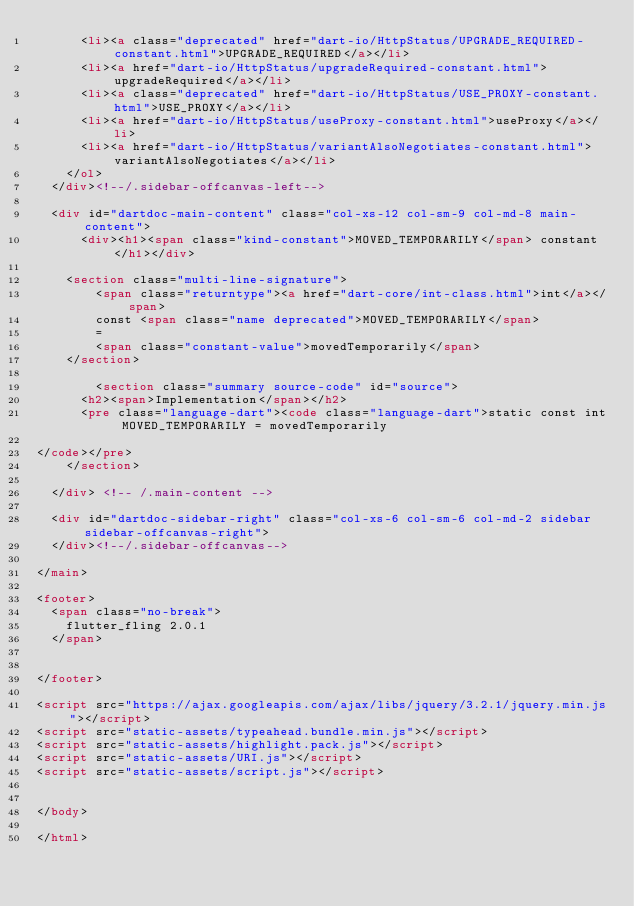<code> <loc_0><loc_0><loc_500><loc_500><_HTML_>      <li><a class="deprecated" href="dart-io/HttpStatus/UPGRADE_REQUIRED-constant.html">UPGRADE_REQUIRED</a></li>
      <li><a href="dart-io/HttpStatus/upgradeRequired-constant.html">upgradeRequired</a></li>
      <li><a class="deprecated" href="dart-io/HttpStatus/USE_PROXY-constant.html">USE_PROXY</a></li>
      <li><a href="dart-io/HttpStatus/useProxy-constant.html">useProxy</a></li>
      <li><a href="dart-io/HttpStatus/variantAlsoNegotiates-constant.html">variantAlsoNegotiates</a></li>
    </ol>
  </div><!--/.sidebar-offcanvas-left-->

  <div id="dartdoc-main-content" class="col-xs-12 col-sm-9 col-md-8 main-content">
      <div><h1><span class="kind-constant">MOVED_TEMPORARILY</span> constant</h1></div>

    <section class="multi-line-signature">
        <span class="returntype"><a href="dart-core/int-class.html">int</a></span>
        const <span class="name deprecated">MOVED_TEMPORARILY</span>
        =
        <span class="constant-value">movedTemporarily</span>
    </section>

        <section class="summary source-code" id="source">
      <h2><span>Implementation</span></h2>
      <pre class="language-dart"><code class="language-dart">static const int MOVED_TEMPORARILY = movedTemporarily

</code></pre>
    </section>

  </div> <!-- /.main-content -->

  <div id="dartdoc-sidebar-right" class="col-xs-6 col-sm-6 col-md-2 sidebar sidebar-offcanvas-right">
  </div><!--/.sidebar-offcanvas-->

</main>

<footer>
  <span class="no-break">
    flutter_fling 2.0.1
  </span>

  
</footer>

<script src="https://ajax.googleapis.com/ajax/libs/jquery/3.2.1/jquery.min.js"></script>
<script src="static-assets/typeahead.bundle.min.js"></script>
<script src="static-assets/highlight.pack.js"></script>
<script src="static-assets/URI.js"></script>
<script src="static-assets/script.js"></script>


</body>

</html>
</code> 